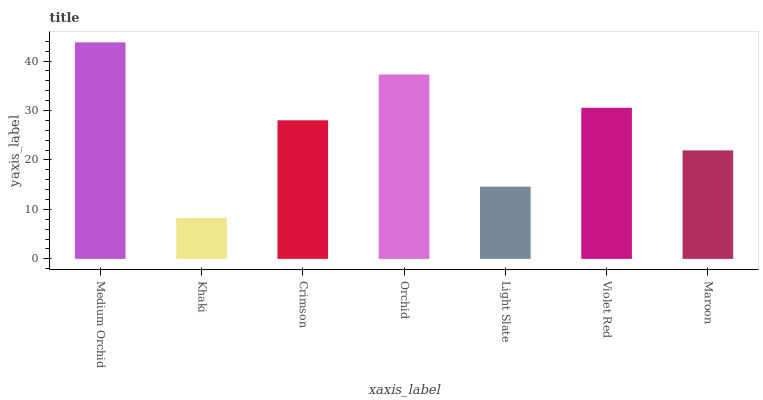Is Khaki the minimum?
Answer yes or no. Yes. Is Medium Orchid the maximum?
Answer yes or no. Yes. Is Crimson the minimum?
Answer yes or no. No. Is Crimson the maximum?
Answer yes or no. No. Is Crimson greater than Khaki?
Answer yes or no. Yes. Is Khaki less than Crimson?
Answer yes or no. Yes. Is Khaki greater than Crimson?
Answer yes or no. No. Is Crimson less than Khaki?
Answer yes or no. No. Is Crimson the high median?
Answer yes or no. Yes. Is Crimson the low median?
Answer yes or no. Yes. Is Violet Red the high median?
Answer yes or no. No. Is Medium Orchid the low median?
Answer yes or no. No. 